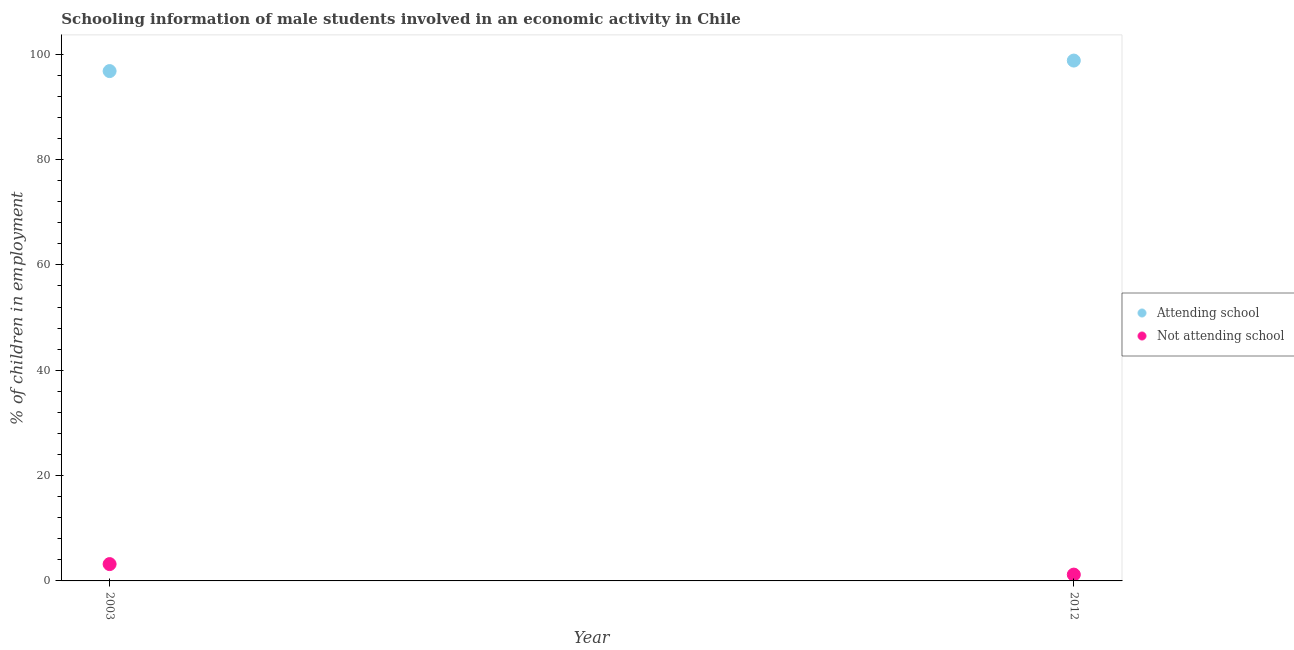Is the number of dotlines equal to the number of legend labels?
Keep it short and to the point. Yes. What is the percentage of employed males who are attending school in 2012?
Provide a succinct answer. 98.8. Across all years, what is the maximum percentage of employed males who are not attending school?
Keep it short and to the point. 3.19. In which year was the percentage of employed males who are attending school maximum?
Provide a short and direct response. 2012. What is the total percentage of employed males who are attending school in the graph?
Offer a very short reply. 195.61. What is the difference between the percentage of employed males who are not attending school in 2003 and that in 2012?
Your response must be concise. 1.99. What is the difference between the percentage of employed males who are not attending school in 2003 and the percentage of employed males who are attending school in 2012?
Provide a succinct answer. -95.61. What is the average percentage of employed males who are attending school per year?
Give a very brief answer. 97.8. In the year 2012, what is the difference between the percentage of employed males who are not attending school and percentage of employed males who are attending school?
Offer a very short reply. -97.6. In how many years, is the percentage of employed males who are not attending school greater than 36 %?
Ensure brevity in your answer.  0. What is the ratio of the percentage of employed males who are attending school in 2003 to that in 2012?
Keep it short and to the point. 0.98. In how many years, is the percentage of employed males who are not attending school greater than the average percentage of employed males who are not attending school taken over all years?
Provide a succinct answer. 1. Does the percentage of employed males who are attending school monotonically increase over the years?
Keep it short and to the point. Yes. Is the percentage of employed males who are attending school strictly greater than the percentage of employed males who are not attending school over the years?
Give a very brief answer. Yes. How many dotlines are there?
Make the answer very short. 2. Does the graph contain grids?
Make the answer very short. No. Where does the legend appear in the graph?
Provide a short and direct response. Center right. What is the title of the graph?
Give a very brief answer. Schooling information of male students involved in an economic activity in Chile. What is the label or title of the Y-axis?
Ensure brevity in your answer.  % of children in employment. What is the % of children in employment in Attending school in 2003?
Offer a very short reply. 96.81. What is the % of children in employment of Not attending school in 2003?
Ensure brevity in your answer.  3.19. What is the % of children in employment of Attending school in 2012?
Your answer should be compact. 98.8. What is the % of children in employment of Not attending school in 2012?
Offer a very short reply. 1.2. Across all years, what is the maximum % of children in employment of Attending school?
Ensure brevity in your answer.  98.8. Across all years, what is the maximum % of children in employment in Not attending school?
Your response must be concise. 3.19. Across all years, what is the minimum % of children in employment in Attending school?
Provide a short and direct response. 96.81. What is the total % of children in employment in Attending school in the graph?
Your answer should be compact. 195.61. What is the total % of children in employment of Not attending school in the graph?
Your answer should be compact. 4.39. What is the difference between the % of children in employment of Attending school in 2003 and that in 2012?
Your answer should be compact. -1.99. What is the difference between the % of children in employment of Not attending school in 2003 and that in 2012?
Keep it short and to the point. 1.99. What is the difference between the % of children in employment of Attending school in 2003 and the % of children in employment of Not attending school in 2012?
Provide a succinct answer. 95.61. What is the average % of children in employment in Attending school per year?
Provide a succinct answer. 97.8. What is the average % of children in employment in Not attending school per year?
Your answer should be very brief. 2.2. In the year 2003, what is the difference between the % of children in employment of Attending school and % of children in employment of Not attending school?
Your answer should be compact. 93.61. In the year 2012, what is the difference between the % of children in employment of Attending school and % of children in employment of Not attending school?
Your answer should be compact. 97.6. What is the ratio of the % of children in employment in Attending school in 2003 to that in 2012?
Keep it short and to the point. 0.98. What is the ratio of the % of children in employment of Not attending school in 2003 to that in 2012?
Make the answer very short. 2.66. What is the difference between the highest and the second highest % of children in employment in Attending school?
Provide a succinct answer. 1.99. What is the difference between the highest and the second highest % of children in employment in Not attending school?
Ensure brevity in your answer.  1.99. What is the difference between the highest and the lowest % of children in employment in Attending school?
Offer a terse response. 1.99. What is the difference between the highest and the lowest % of children in employment in Not attending school?
Ensure brevity in your answer.  1.99. 